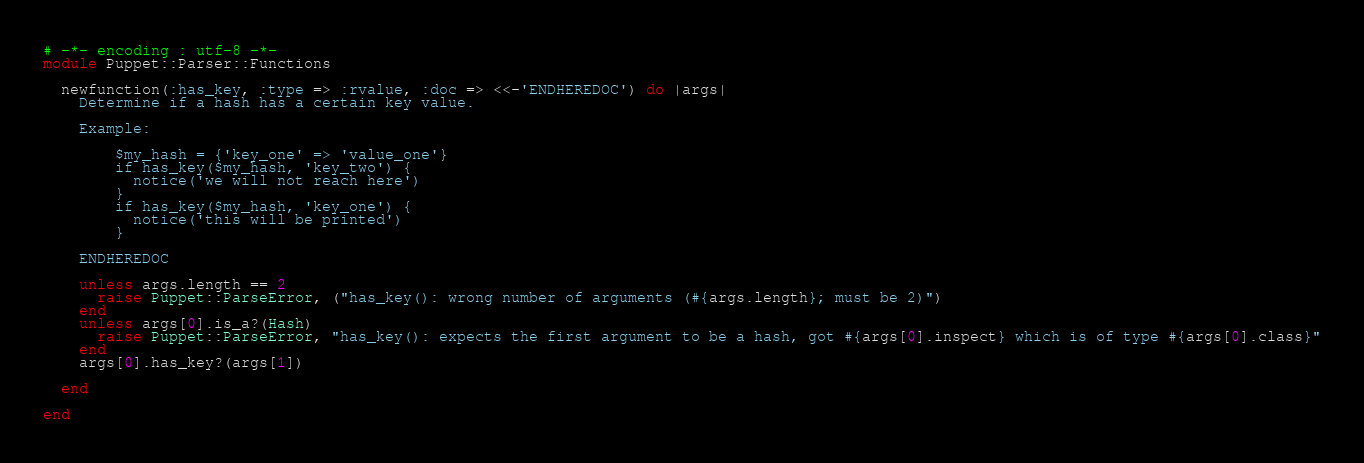<code> <loc_0><loc_0><loc_500><loc_500><_Ruby_># -*- encoding : utf-8 -*-
module Puppet::Parser::Functions

  newfunction(:has_key, :type => :rvalue, :doc => <<-'ENDHEREDOC') do |args|
    Determine if a hash has a certain key value.

    Example:

        $my_hash = {'key_one' => 'value_one'}
        if has_key($my_hash, 'key_two') {
          notice('we will not reach here')
        }
        if has_key($my_hash, 'key_one') {
          notice('this will be printed')
        }

    ENDHEREDOC

    unless args.length == 2
      raise Puppet::ParseError, ("has_key(): wrong number of arguments (#{args.length}; must be 2)")
    end
    unless args[0].is_a?(Hash)
      raise Puppet::ParseError, "has_key(): expects the first argument to be a hash, got #{args[0].inspect} which is of type #{args[0].class}"
    end
    args[0].has_key?(args[1])

  end

end
</code> 